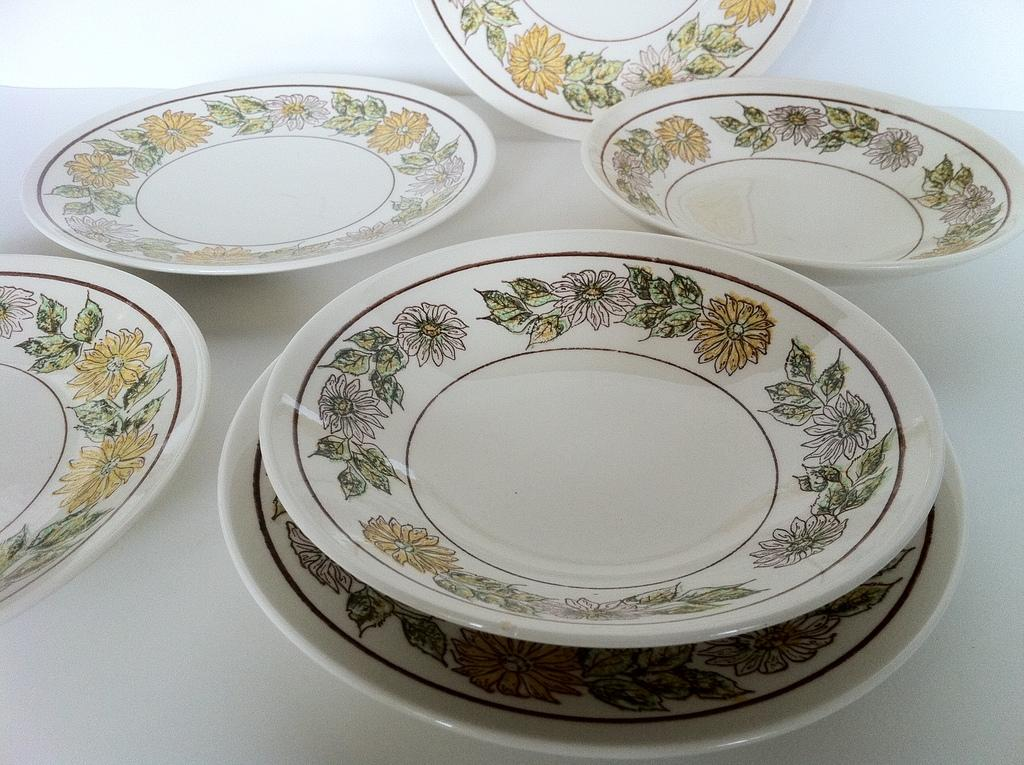What color are the plates in the image? The plates in the image are white. What design is featured on the plates? The plates have a design of flowers. What type of coal is used to fuel the queen's carriage in the image? There is no queen, carriage, or coal present in the image. The image only features white plates with a design of flowers. 